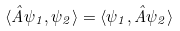Convert formula to latex. <formula><loc_0><loc_0><loc_500><loc_500>\langle \hat { A } \psi _ { 1 } , \psi _ { 2 } \rangle = \langle \psi _ { 1 } , \hat { A } \psi _ { 2 } \rangle</formula> 